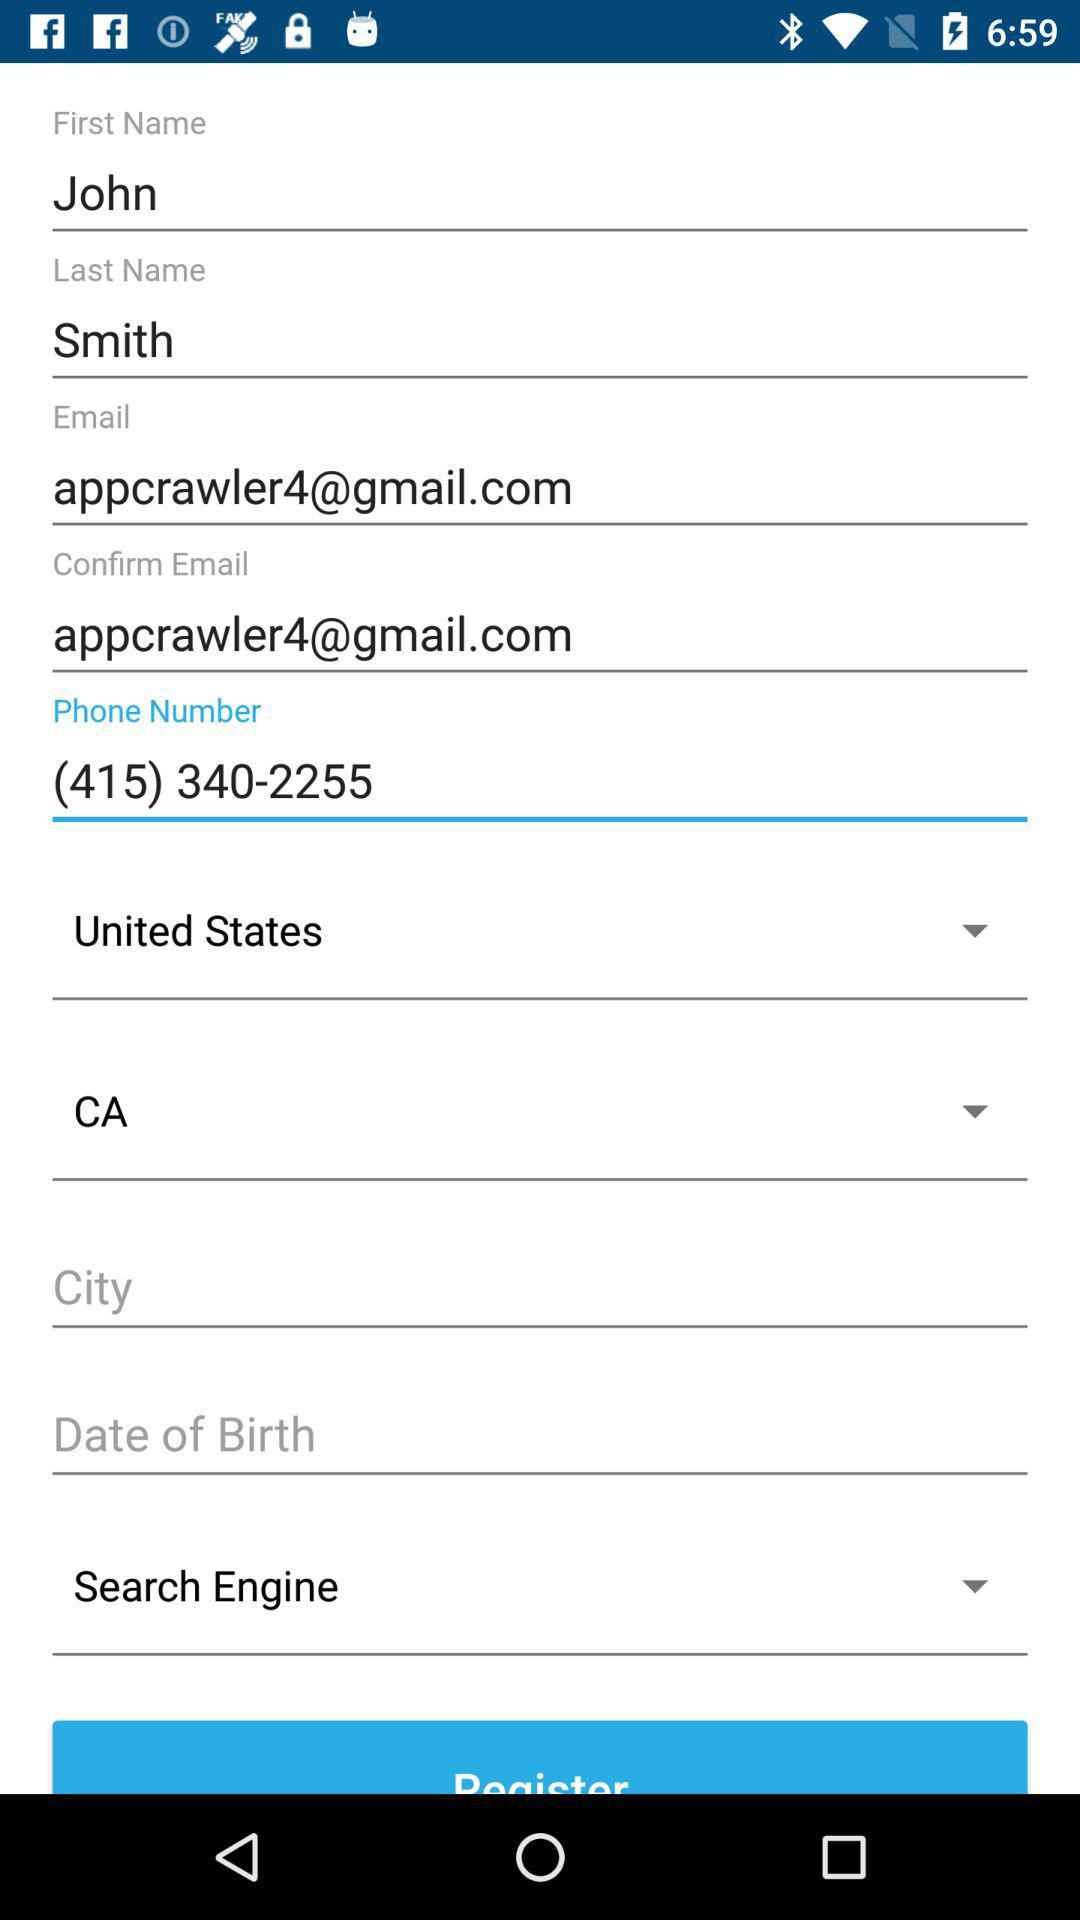How many text inputs have the value 'appcrawler4@gmail.com'?
Answer the question using a single word or phrase. 2 